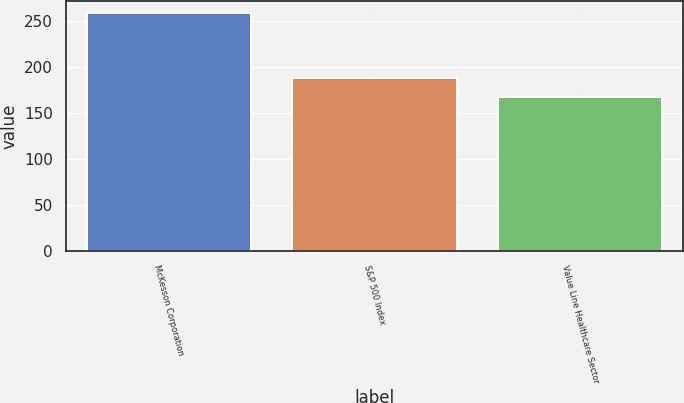Convert chart. <chart><loc_0><loc_0><loc_500><loc_500><bar_chart><fcel>McKesson Corporation<fcel>S&P 500 Index<fcel>Value Line Healthcare Sector<nl><fcel>258<fcel>188<fcel>167.52<nl></chart> 